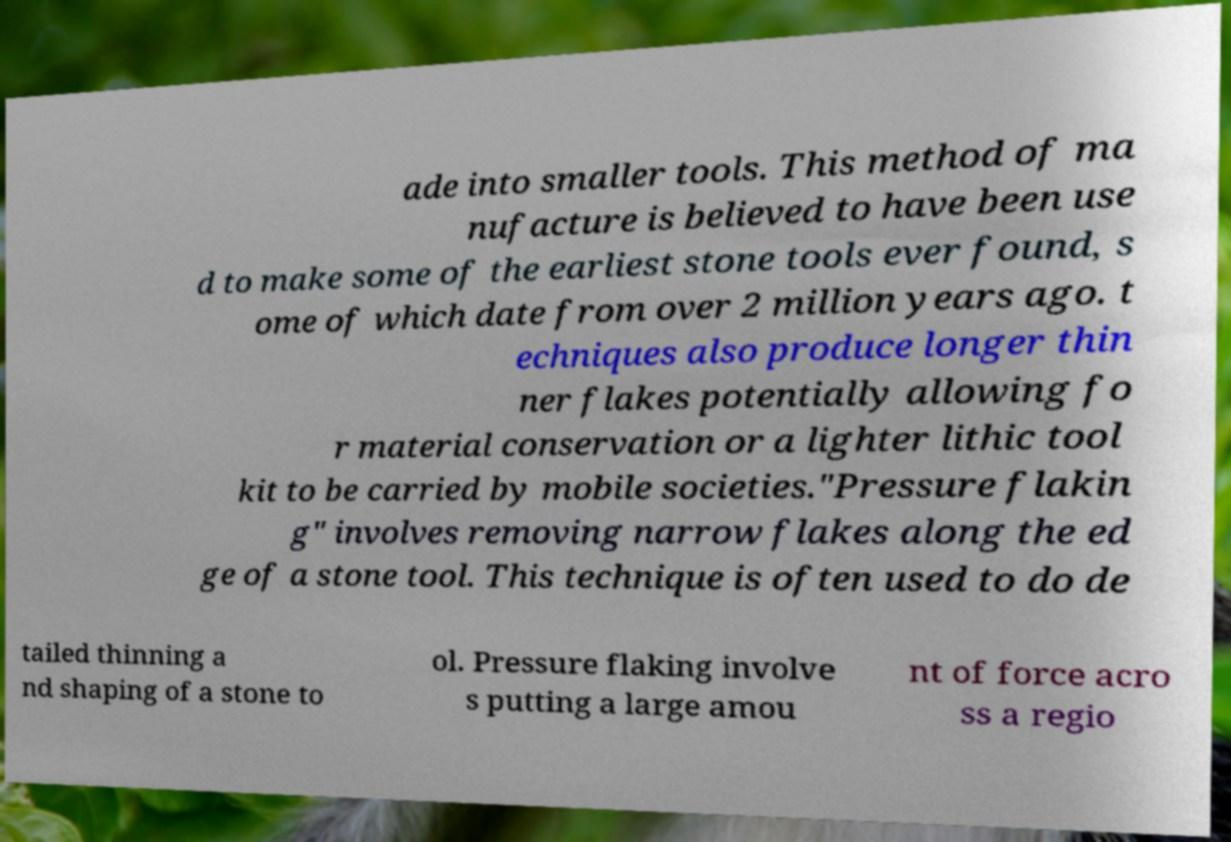Please identify and transcribe the text found in this image. ade into smaller tools. This method of ma nufacture is believed to have been use d to make some of the earliest stone tools ever found, s ome of which date from over 2 million years ago. t echniques also produce longer thin ner flakes potentially allowing fo r material conservation or a lighter lithic tool kit to be carried by mobile societies."Pressure flakin g" involves removing narrow flakes along the ed ge of a stone tool. This technique is often used to do de tailed thinning a nd shaping of a stone to ol. Pressure flaking involve s putting a large amou nt of force acro ss a regio 